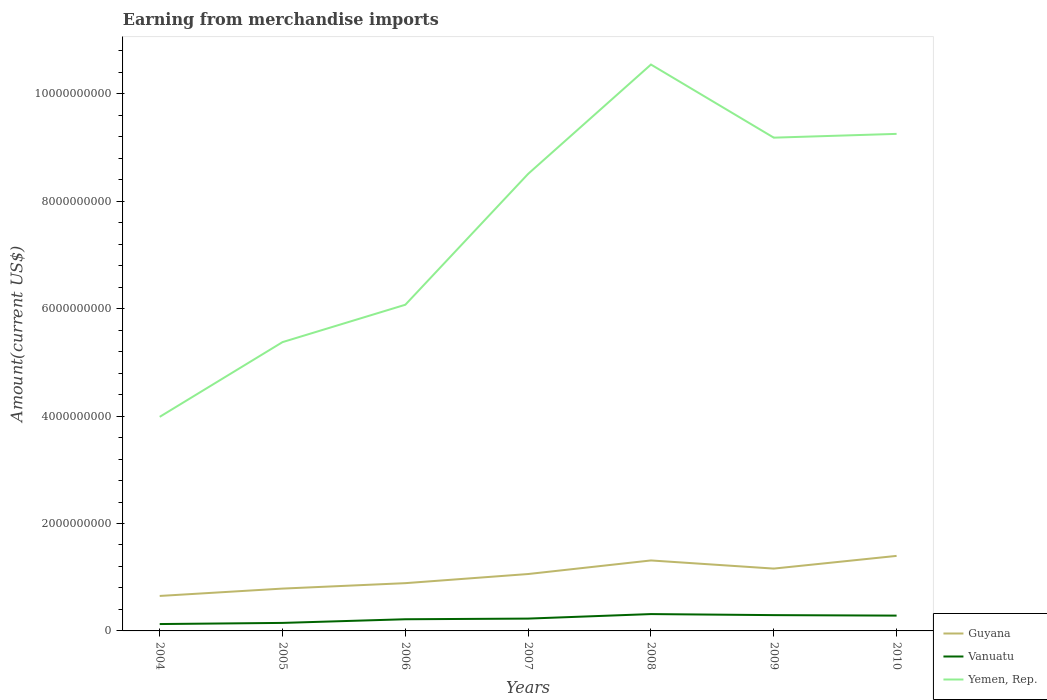How many different coloured lines are there?
Offer a terse response. 3. Does the line corresponding to Guyana intersect with the line corresponding to Yemen, Rep.?
Give a very brief answer. No. Is the number of lines equal to the number of legend labels?
Offer a very short reply. Yes. Across all years, what is the maximum amount earned from merchandise imports in Yemen, Rep.?
Provide a short and direct response. 3.99e+09. In which year was the amount earned from merchandise imports in Vanuatu maximum?
Your response must be concise. 2004. What is the total amount earned from merchandise imports in Guyana in the graph?
Your answer should be very brief. -1.37e+08. What is the difference between the highest and the second highest amount earned from merchandise imports in Vanuatu?
Give a very brief answer. 1.86e+08. Is the amount earned from merchandise imports in Yemen, Rep. strictly greater than the amount earned from merchandise imports in Guyana over the years?
Provide a succinct answer. No. How many lines are there?
Keep it short and to the point. 3. Does the graph contain grids?
Provide a short and direct response. No. Where does the legend appear in the graph?
Give a very brief answer. Bottom right. How are the legend labels stacked?
Offer a very short reply. Vertical. What is the title of the graph?
Provide a short and direct response. Earning from merchandise imports. What is the label or title of the Y-axis?
Provide a short and direct response. Amount(current US$). What is the Amount(current US$) of Guyana in 2004?
Provide a succinct answer. 6.51e+08. What is the Amount(current US$) of Vanuatu in 2004?
Ensure brevity in your answer.  1.28e+08. What is the Amount(current US$) in Yemen, Rep. in 2004?
Provide a short and direct response. 3.99e+09. What is the Amount(current US$) of Guyana in 2005?
Ensure brevity in your answer.  7.88e+08. What is the Amount(current US$) in Vanuatu in 2005?
Your response must be concise. 1.49e+08. What is the Amount(current US$) of Yemen, Rep. in 2005?
Provide a short and direct response. 5.38e+09. What is the Amount(current US$) of Guyana in 2006?
Provide a succinct answer. 8.89e+08. What is the Amount(current US$) of Vanuatu in 2006?
Your response must be concise. 2.17e+08. What is the Amount(current US$) of Yemen, Rep. in 2006?
Offer a very short reply. 6.07e+09. What is the Amount(current US$) of Guyana in 2007?
Provide a short and direct response. 1.06e+09. What is the Amount(current US$) in Vanuatu in 2007?
Your answer should be very brief. 2.29e+08. What is the Amount(current US$) of Yemen, Rep. in 2007?
Give a very brief answer. 8.51e+09. What is the Amount(current US$) of Guyana in 2008?
Your answer should be compact. 1.31e+09. What is the Amount(current US$) in Vanuatu in 2008?
Provide a succinct answer. 3.14e+08. What is the Amount(current US$) in Yemen, Rep. in 2008?
Your answer should be compact. 1.05e+1. What is the Amount(current US$) of Guyana in 2009?
Make the answer very short. 1.16e+09. What is the Amount(current US$) in Vanuatu in 2009?
Keep it short and to the point. 2.94e+08. What is the Amount(current US$) of Yemen, Rep. in 2009?
Make the answer very short. 9.18e+09. What is the Amount(current US$) of Guyana in 2010?
Provide a succinct answer. 1.40e+09. What is the Amount(current US$) in Vanuatu in 2010?
Your answer should be very brief. 2.85e+08. What is the Amount(current US$) of Yemen, Rep. in 2010?
Your answer should be very brief. 9.26e+09. Across all years, what is the maximum Amount(current US$) in Guyana?
Provide a succinct answer. 1.40e+09. Across all years, what is the maximum Amount(current US$) of Vanuatu?
Make the answer very short. 3.14e+08. Across all years, what is the maximum Amount(current US$) of Yemen, Rep.?
Make the answer very short. 1.05e+1. Across all years, what is the minimum Amount(current US$) in Guyana?
Provide a succinct answer. 6.51e+08. Across all years, what is the minimum Amount(current US$) in Vanuatu?
Provide a succinct answer. 1.28e+08. Across all years, what is the minimum Amount(current US$) in Yemen, Rep.?
Ensure brevity in your answer.  3.99e+09. What is the total Amount(current US$) of Guyana in the graph?
Offer a terse response. 7.26e+09. What is the total Amount(current US$) of Vanuatu in the graph?
Offer a very short reply. 1.62e+09. What is the total Amount(current US$) of Yemen, Rep. in the graph?
Your answer should be very brief. 5.29e+1. What is the difference between the Amount(current US$) in Guyana in 2004 and that in 2005?
Keep it short and to the point. -1.37e+08. What is the difference between the Amount(current US$) of Vanuatu in 2004 and that in 2005?
Keep it short and to the point. -2.12e+07. What is the difference between the Amount(current US$) of Yemen, Rep. in 2004 and that in 2005?
Your answer should be compact. -1.39e+09. What is the difference between the Amount(current US$) of Guyana in 2004 and that in 2006?
Your answer should be very brief. -2.38e+08. What is the difference between the Amount(current US$) in Vanuatu in 2004 and that in 2006?
Offer a terse response. -8.93e+07. What is the difference between the Amount(current US$) in Yemen, Rep. in 2004 and that in 2006?
Provide a short and direct response. -2.09e+09. What is the difference between the Amount(current US$) in Guyana in 2004 and that in 2007?
Provide a short and direct response. -4.08e+08. What is the difference between the Amount(current US$) in Vanuatu in 2004 and that in 2007?
Ensure brevity in your answer.  -1.01e+08. What is the difference between the Amount(current US$) in Yemen, Rep. in 2004 and that in 2007?
Provide a short and direct response. -4.52e+09. What is the difference between the Amount(current US$) in Guyana in 2004 and that in 2008?
Give a very brief answer. -6.61e+08. What is the difference between the Amount(current US$) in Vanuatu in 2004 and that in 2008?
Provide a short and direct response. -1.86e+08. What is the difference between the Amount(current US$) in Yemen, Rep. in 2004 and that in 2008?
Your answer should be compact. -6.56e+09. What is the difference between the Amount(current US$) in Guyana in 2004 and that in 2009?
Offer a very short reply. -5.09e+08. What is the difference between the Amount(current US$) of Vanuatu in 2004 and that in 2009?
Keep it short and to the point. -1.66e+08. What is the difference between the Amount(current US$) of Yemen, Rep. in 2004 and that in 2009?
Keep it short and to the point. -5.20e+09. What is the difference between the Amount(current US$) of Guyana in 2004 and that in 2010?
Offer a very short reply. -7.46e+08. What is the difference between the Amount(current US$) in Vanuatu in 2004 and that in 2010?
Your answer should be very brief. -1.57e+08. What is the difference between the Amount(current US$) in Yemen, Rep. in 2004 and that in 2010?
Provide a short and direct response. -5.27e+09. What is the difference between the Amount(current US$) of Guyana in 2005 and that in 2006?
Your answer should be compact. -1.01e+08. What is the difference between the Amount(current US$) of Vanuatu in 2005 and that in 2006?
Keep it short and to the point. -6.81e+07. What is the difference between the Amount(current US$) in Yemen, Rep. in 2005 and that in 2006?
Your answer should be very brief. -6.96e+08. What is the difference between the Amount(current US$) in Guyana in 2005 and that in 2007?
Provide a short and direct response. -2.71e+08. What is the difference between the Amount(current US$) of Vanuatu in 2005 and that in 2007?
Your answer should be compact. -8.03e+07. What is the difference between the Amount(current US$) of Yemen, Rep. in 2005 and that in 2007?
Your answer should be compact. -3.13e+09. What is the difference between the Amount(current US$) in Guyana in 2005 and that in 2008?
Your response must be concise. -5.24e+08. What is the difference between the Amount(current US$) in Vanuatu in 2005 and that in 2008?
Offer a very short reply. -1.64e+08. What is the difference between the Amount(current US$) of Yemen, Rep. in 2005 and that in 2008?
Provide a succinct answer. -5.17e+09. What is the difference between the Amount(current US$) in Guyana in 2005 and that in 2009?
Your answer should be compact. -3.72e+08. What is the difference between the Amount(current US$) in Vanuatu in 2005 and that in 2009?
Offer a terse response. -1.45e+08. What is the difference between the Amount(current US$) in Yemen, Rep. in 2005 and that in 2009?
Provide a short and direct response. -3.81e+09. What is the difference between the Amount(current US$) in Guyana in 2005 and that in 2010?
Offer a very short reply. -6.09e+08. What is the difference between the Amount(current US$) in Vanuatu in 2005 and that in 2010?
Provide a short and direct response. -1.36e+08. What is the difference between the Amount(current US$) of Yemen, Rep. in 2005 and that in 2010?
Make the answer very short. -3.88e+09. What is the difference between the Amount(current US$) of Guyana in 2006 and that in 2007?
Provide a succinct answer. -1.70e+08. What is the difference between the Amount(current US$) of Vanuatu in 2006 and that in 2007?
Your answer should be compact. -1.22e+07. What is the difference between the Amount(current US$) of Yemen, Rep. in 2006 and that in 2007?
Ensure brevity in your answer.  -2.44e+09. What is the difference between the Amount(current US$) of Guyana in 2006 and that in 2008?
Offer a terse response. -4.23e+08. What is the difference between the Amount(current US$) in Vanuatu in 2006 and that in 2008?
Your answer should be very brief. -9.63e+07. What is the difference between the Amount(current US$) in Yemen, Rep. in 2006 and that in 2008?
Offer a terse response. -4.47e+09. What is the difference between the Amount(current US$) in Guyana in 2006 and that in 2009?
Ensure brevity in your answer.  -2.71e+08. What is the difference between the Amount(current US$) in Vanuatu in 2006 and that in 2009?
Provide a short and direct response. -7.68e+07. What is the difference between the Amount(current US$) of Yemen, Rep. in 2006 and that in 2009?
Keep it short and to the point. -3.11e+09. What is the difference between the Amount(current US$) of Guyana in 2006 and that in 2010?
Provide a short and direct response. -5.08e+08. What is the difference between the Amount(current US$) of Vanuatu in 2006 and that in 2010?
Give a very brief answer. -6.78e+07. What is the difference between the Amount(current US$) in Yemen, Rep. in 2006 and that in 2010?
Ensure brevity in your answer.  -3.18e+09. What is the difference between the Amount(current US$) in Guyana in 2007 and that in 2008?
Keep it short and to the point. -2.53e+08. What is the difference between the Amount(current US$) in Vanuatu in 2007 and that in 2008?
Give a very brief answer. -8.41e+07. What is the difference between the Amount(current US$) of Yemen, Rep. in 2007 and that in 2008?
Keep it short and to the point. -2.04e+09. What is the difference between the Amount(current US$) in Guyana in 2007 and that in 2009?
Offer a very short reply. -1.01e+08. What is the difference between the Amount(current US$) in Vanuatu in 2007 and that in 2009?
Provide a succinct answer. -6.47e+07. What is the difference between the Amount(current US$) in Yemen, Rep. in 2007 and that in 2009?
Make the answer very short. -6.74e+08. What is the difference between the Amount(current US$) of Guyana in 2007 and that in 2010?
Offer a terse response. -3.38e+08. What is the difference between the Amount(current US$) of Vanuatu in 2007 and that in 2010?
Provide a short and direct response. -5.56e+07. What is the difference between the Amount(current US$) of Yemen, Rep. in 2007 and that in 2010?
Offer a very short reply. -7.45e+08. What is the difference between the Amount(current US$) of Guyana in 2008 and that in 2009?
Give a very brief answer. 1.52e+08. What is the difference between the Amount(current US$) in Vanuatu in 2008 and that in 2009?
Your answer should be compact. 1.95e+07. What is the difference between the Amount(current US$) in Yemen, Rep. in 2008 and that in 2009?
Give a very brief answer. 1.36e+09. What is the difference between the Amount(current US$) of Guyana in 2008 and that in 2010?
Offer a terse response. -8.49e+07. What is the difference between the Amount(current US$) in Vanuatu in 2008 and that in 2010?
Ensure brevity in your answer.  2.85e+07. What is the difference between the Amount(current US$) of Yemen, Rep. in 2008 and that in 2010?
Provide a succinct answer. 1.29e+09. What is the difference between the Amount(current US$) of Guyana in 2009 and that in 2010?
Ensure brevity in your answer.  -2.36e+08. What is the difference between the Amount(current US$) of Vanuatu in 2009 and that in 2010?
Ensure brevity in your answer.  9.04e+06. What is the difference between the Amount(current US$) of Yemen, Rep. in 2009 and that in 2010?
Make the answer very short. -7.05e+07. What is the difference between the Amount(current US$) in Guyana in 2004 and the Amount(current US$) in Vanuatu in 2005?
Keep it short and to the point. 5.02e+08. What is the difference between the Amount(current US$) in Guyana in 2004 and the Amount(current US$) in Yemen, Rep. in 2005?
Provide a short and direct response. -4.73e+09. What is the difference between the Amount(current US$) in Vanuatu in 2004 and the Amount(current US$) in Yemen, Rep. in 2005?
Your answer should be very brief. -5.25e+09. What is the difference between the Amount(current US$) of Guyana in 2004 and the Amount(current US$) of Vanuatu in 2006?
Give a very brief answer. 4.34e+08. What is the difference between the Amount(current US$) in Guyana in 2004 and the Amount(current US$) in Yemen, Rep. in 2006?
Ensure brevity in your answer.  -5.42e+09. What is the difference between the Amount(current US$) of Vanuatu in 2004 and the Amount(current US$) of Yemen, Rep. in 2006?
Your answer should be compact. -5.95e+09. What is the difference between the Amount(current US$) in Guyana in 2004 and the Amount(current US$) in Vanuatu in 2007?
Your answer should be very brief. 4.22e+08. What is the difference between the Amount(current US$) of Guyana in 2004 and the Amount(current US$) of Yemen, Rep. in 2007?
Provide a short and direct response. -7.86e+09. What is the difference between the Amount(current US$) in Vanuatu in 2004 and the Amount(current US$) in Yemen, Rep. in 2007?
Ensure brevity in your answer.  -8.38e+09. What is the difference between the Amount(current US$) in Guyana in 2004 and the Amount(current US$) in Vanuatu in 2008?
Provide a short and direct response. 3.38e+08. What is the difference between the Amount(current US$) of Guyana in 2004 and the Amount(current US$) of Yemen, Rep. in 2008?
Your response must be concise. -9.89e+09. What is the difference between the Amount(current US$) in Vanuatu in 2004 and the Amount(current US$) in Yemen, Rep. in 2008?
Your answer should be very brief. -1.04e+1. What is the difference between the Amount(current US$) in Guyana in 2004 and the Amount(current US$) in Vanuatu in 2009?
Make the answer very short. 3.57e+08. What is the difference between the Amount(current US$) in Guyana in 2004 and the Amount(current US$) in Yemen, Rep. in 2009?
Your answer should be very brief. -8.53e+09. What is the difference between the Amount(current US$) in Vanuatu in 2004 and the Amount(current US$) in Yemen, Rep. in 2009?
Your response must be concise. -9.06e+09. What is the difference between the Amount(current US$) of Guyana in 2004 and the Amount(current US$) of Vanuatu in 2010?
Give a very brief answer. 3.66e+08. What is the difference between the Amount(current US$) of Guyana in 2004 and the Amount(current US$) of Yemen, Rep. in 2010?
Provide a succinct answer. -8.60e+09. What is the difference between the Amount(current US$) in Vanuatu in 2004 and the Amount(current US$) in Yemen, Rep. in 2010?
Give a very brief answer. -9.13e+09. What is the difference between the Amount(current US$) in Guyana in 2005 and the Amount(current US$) in Vanuatu in 2006?
Ensure brevity in your answer.  5.71e+08. What is the difference between the Amount(current US$) in Guyana in 2005 and the Amount(current US$) in Yemen, Rep. in 2006?
Your response must be concise. -5.29e+09. What is the difference between the Amount(current US$) of Vanuatu in 2005 and the Amount(current US$) of Yemen, Rep. in 2006?
Provide a succinct answer. -5.92e+09. What is the difference between the Amount(current US$) in Guyana in 2005 and the Amount(current US$) in Vanuatu in 2007?
Your response must be concise. 5.59e+08. What is the difference between the Amount(current US$) of Guyana in 2005 and the Amount(current US$) of Yemen, Rep. in 2007?
Your response must be concise. -7.72e+09. What is the difference between the Amount(current US$) of Vanuatu in 2005 and the Amount(current US$) of Yemen, Rep. in 2007?
Keep it short and to the point. -8.36e+09. What is the difference between the Amount(current US$) in Guyana in 2005 and the Amount(current US$) in Vanuatu in 2008?
Give a very brief answer. 4.75e+08. What is the difference between the Amount(current US$) in Guyana in 2005 and the Amount(current US$) in Yemen, Rep. in 2008?
Provide a succinct answer. -9.76e+09. What is the difference between the Amount(current US$) of Vanuatu in 2005 and the Amount(current US$) of Yemen, Rep. in 2008?
Your answer should be compact. -1.04e+1. What is the difference between the Amount(current US$) of Guyana in 2005 and the Amount(current US$) of Vanuatu in 2009?
Keep it short and to the point. 4.94e+08. What is the difference between the Amount(current US$) of Guyana in 2005 and the Amount(current US$) of Yemen, Rep. in 2009?
Offer a terse response. -8.40e+09. What is the difference between the Amount(current US$) in Vanuatu in 2005 and the Amount(current US$) in Yemen, Rep. in 2009?
Give a very brief answer. -9.04e+09. What is the difference between the Amount(current US$) of Guyana in 2005 and the Amount(current US$) of Vanuatu in 2010?
Ensure brevity in your answer.  5.03e+08. What is the difference between the Amount(current US$) of Guyana in 2005 and the Amount(current US$) of Yemen, Rep. in 2010?
Keep it short and to the point. -8.47e+09. What is the difference between the Amount(current US$) of Vanuatu in 2005 and the Amount(current US$) of Yemen, Rep. in 2010?
Offer a terse response. -9.11e+09. What is the difference between the Amount(current US$) of Guyana in 2006 and the Amount(current US$) of Vanuatu in 2007?
Keep it short and to the point. 6.60e+08. What is the difference between the Amount(current US$) of Guyana in 2006 and the Amount(current US$) of Yemen, Rep. in 2007?
Provide a succinct answer. -7.62e+09. What is the difference between the Amount(current US$) of Vanuatu in 2006 and the Amount(current US$) of Yemen, Rep. in 2007?
Keep it short and to the point. -8.29e+09. What is the difference between the Amount(current US$) of Guyana in 2006 and the Amount(current US$) of Vanuatu in 2008?
Offer a very short reply. 5.76e+08. What is the difference between the Amount(current US$) in Guyana in 2006 and the Amount(current US$) in Yemen, Rep. in 2008?
Provide a short and direct response. -9.66e+09. What is the difference between the Amount(current US$) in Vanuatu in 2006 and the Amount(current US$) in Yemen, Rep. in 2008?
Your answer should be very brief. -1.03e+1. What is the difference between the Amount(current US$) in Guyana in 2006 and the Amount(current US$) in Vanuatu in 2009?
Your answer should be compact. 5.95e+08. What is the difference between the Amount(current US$) in Guyana in 2006 and the Amount(current US$) in Yemen, Rep. in 2009?
Your answer should be very brief. -8.30e+09. What is the difference between the Amount(current US$) of Vanuatu in 2006 and the Amount(current US$) of Yemen, Rep. in 2009?
Your answer should be compact. -8.97e+09. What is the difference between the Amount(current US$) of Guyana in 2006 and the Amount(current US$) of Vanuatu in 2010?
Offer a terse response. 6.04e+08. What is the difference between the Amount(current US$) in Guyana in 2006 and the Amount(current US$) in Yemen, Rep. in 2010?
Make the answer very short. -8.37e+09. What is the difference between the Amount(current US$) in Vanuatu in 2006 and the Amount(current US$) in Yemen, Rep. in 2010?
Offer a terse response. -9.04e+09. What is the difference between the Amount(current US$) of Guyana in 2007 and the Amount(current US$) of Vanuatu in 2008?
Offer a terse response. 7.46e+08. What is the difference between the Amount(current US$) in Guyana in 2007 and the Amount(current US$) in Yemen, Rep. in 2008?
Keep it short and to the point. -9.49e+09. What is the difference between the Amount(current US$) in Vanuatu in 2007 and the Amount(current US$) in Yemen, Rep. in 2008?
Provide a short and direct response. -1.03e+1. What is the difference between the Amount(current US$) in Guyana in 2007 and the Amount(current US$) in Vanuatu in 2009?
Provide a short and direct response. 7.65e+08. What is the difference between the Amount(current US$) of Guyana in 2007 and the Amount(current US$) of Yemen, Rep. in 2009?
Keep it short and to the point. -8.13e+09. What is the difference between the Amount(current US$) of Vanuatu in 2007 and the Amount(current US$) of Yemen, Rep. in 2009?
Your response must be concise. -8.96e+09. What is the difference between the Amount(current US$) in Guyana in 2007 and the Amount(current US$) in Vanuatu in 2010?
Your answer should be very brief. 7.74e+08. What is the difference between the Amount(current US$) in Guyana in 2007 and the Amount(current US$) in Yemen, Rep. in 2010?
Give a very brief answer. -8.20e+09. What is the difference between the Amount(current US$) in Vanuatu in 2007 and the Amount(current US$) in Yemen, Rep. in 2010?
Offer a terse response. -9.03e+09. What is the difference between the Amount(current US$) in Guyana in 2008 and the Amount(current US$) in Vanuatu in 2009?
Give a very brief answer. 1.02e+09. What is the difference between the Amount(current US$) in Guyana in 2008 and the Amount(current US$) in Yemen, Rep. in 2009?
Provide a short and direct response. -7.87e+09. What is the difference between the Amount(current US$) in Vanuatu in 2008 and the Amount(current US$) in Yemen, Rep. in 2009?
Ensure brevity in your answer.  -8.87e+09. What is the difference between the Amount(current US$) of Guyana in 2008 and the Amount(current US$) of Vanuatu in 2010?
Provide a succinct answer. 1.03e+09. What is the difference between the Amount(current US$) in Guyana in 2008 and the Amount(current US$) in Yemen, Rep. in 2010?
Give a very brief answer. -7.94e+09. What is the difference between the Amount(current US$) in Vanuatu in 2008 and the Amount(current US$) in Yemen, Rep. in 2010?
Provide a short and direct response. -8.94e+09. What is the difference between the Amount(current US$) of Guyana in 2009 and the Amount(current US$) of Vanuatu in 2010?
Give a very brief answer. 8.76e+08. What is the difference between the Amount(current US$) in Guyana in 2009 and the Amount(current US$) in Yemen, Rep. in 2010?
Keep it short and to the point. -8.09e+09. What is the difference between the Amount(current US$) of Vanuatu in 2009 and the Amount(current US$) of Yemen, Rep. in 2010?
Offer a very short reply. -8.96e+09. What is the average Amount(current US$) of Guyana per year?
Provide a succinct answer. 1.04e+09. What is the average Amount(current US$) of Vanuatu per year?
Your answer should be very brief. 2.31e+08. What is the average Amount(current US$) of Yemen, Rep. per year?
Your response must be concise. 7.56e+09. In the year 2004, what is the difference between the Amount(current US$) of Guyana and Amount(current US$) of Vanuatu?
Provide a short and direct response. 5.23e+08. In the year 2004, what is the difference between the Amount(current US$) of Guyana and Amount(current US$) of Yemen, Rep.?
Your answer should be very brief. -3.33e+09. In the year 2004, what is the difference between the Amount(current US$) of Vanuatu and Amount(current US$) of Yemen, Rep.?
Ensure brevity in your answer.  -3.86e+09. In the year 2005, what is the difference between the Amount(current US$) of Guyana and Amount(current US$) of Vanuatu?
Offer a very short reply. 6.39e+08. In the year 2005, what is the difference between the Amount(current US$) of Guyana and Amount(current US$) of Yemen, Rep.?
Provide a succinct answer. -4.59e+09. In the year 2005, what is the difference between the Amount(current US$) in Vanuatu and Amount(current US$) in Yemen, Rep.?
Give a very brief answer. -5.23e+09. In the year 2006, what is the difference between the Amount(current US$) in Guyana and Amount(current US$) in Vanuatu?
Give a very brief answer. 6.72e+08. In the year 2006, what is the difference between the Amount(current US$) of Guyana and Amount(current US$) of Yemen, Rep.?
Give a very brief answer. -5.18e+09. In the year 2006, what is the difference between the Amount(current US$) of Vanuatu and Amount(current US$) of Yemen, Rep.?
Give a very brief answer. -5.86e+09. In the year 2007, what is the difference between the Amount(current US$) in Guyana and Amount(current US$) in Vanuatu?
Your answer should be compact. 8.30e+08. In the year 2007, what is the difference between the Amount(current US$) in Guyana and Amount(current US$) in Yemen, Rep.?
Keep it short and to the point. -7.45e+09. In the year 2007, what is the difference between the Amount(current US$) of Vanuatu and Amount(current US$) of Yemen, Rep.?
Your response must be concise. -8.28e+09. In the year 2008, what is the difference between the Amount(current US$) of Guyana and Amount(current US$) of Vanuatu?
Keep it short and to the point. 9.99e+08. In the year 2008, what is the difference between the Amount(current US$) in Guyana and Amount(current US$) in Yemen, Rep.?
Give a very brief answer. -9.23e+09. In the year 2008, what is the difference between the Amount(current US$) in Vanuatu and Amount(current US$) in Yemen, Rep.?
Your answer should be compact. -1.02e+1. In the year 2009, what is the difference between the Amount(current US$) in Guyana and Amount(current US$) in Vanuatu?
Your answer should be compact. 8.67e+08. In the year 2009, what is the difference between the Amount(current US$) of Guyana and Amount(current US$) of Yemen, Rep.?
Offer a terse response. -8.02e+09. In the year 2009, what is the difference between the Amount(current US$) in Vanuatu and Amount(current US$) in Yemen, Rep.?
Your response must be concise. -8.89e+09. In the year 2010, what is the difference between the Amount(current US$) in Guyana and Amount(current US$) in Vanuatu?
Your response must be concise. 1.11e+09. In the year 2010, what is the difference between the Amount(current US$) of Guyana and Amount(current US$) of Yemen, Rep.?
Make the answer very short. -7.86e+09. In the year 2010, what is the difference between the Amount(current US$) of Vanuatu and Amount(current US$) of Yemen, Rep.?
Provide a succinct answer. -8.97e+09. What is the ratio of the Amount(current US$) of Guyana in 2004 to that in 2005?
Offer a very short reply. 0.83. What is the ratio of the Amount(current US$) of Vanuatu in 2004 to that in 2005?
Provide a short and direct response. 0.86. What is the ratio of the Amount(current US$) of Yemen, Rep. in 2004 to that in 2005?
Provide a succinct answer. 0.74. What is the ratio of the Amount(current US$) in Guyana in 2004 to that in 2006?
Your answer should be very brief. 0.73. What is the ratio of the Amount(current US$) of Vanuatu in 2004 to that in 2006?
Provide a short and direct response. 0.59. What is the ratio of the Amount(current US$) in Yemen, Rep. in 2004 to that in 2006?
Your response must be concise. 0.66. What is the ratio of the Amount(current US$) of Guyana in 2004 to that in 2007?
Your answer should be compact. 0.61. What is the ratio of the Amount(current US$) of Vanuatu in 2004 to that in 2007?
Offer a terse response. 0.56. What is the ratio of the Amount(current US$) in Yemen, Rep. in 2004 to that in 2007?
Give a very brief answer. 0.47. What is the ratio of the Amount(current US$) of Guyana in 2004 to that in 2008?
Provide a short and direct response. 0.5. What is the ratio of the Amount(current US$) of Vanuatu in 2004 to that in 2008?
Provide a succinct answer. 0.41. What is the ratio of the Amount(current US$) in Yemen, Rep. in 2004 to that in 2008?
Offer a very short reply. 0.38. What is the ratio of the Amount(current US$) of Guyana in 2004 to that in 2009?
Your answer should be compact. 0.56. What is the ratio of the Amount(current US$) of Vanuatu in 2004 to that in 2009?
Offer a very short reply. 0.44. What is the ratio of the Amount(current US$) in Yemen, Rep. in 2004 to that in 2009?
Your response must be concise. 0.43. What is the ratio of the Amount(current US$) of Guyana in 2004 to that in 2010?
Provide a succinct answer. 0.47. What is the ratio of the Amount(current US$) of Vanuatu in 2004 to that in 2010?
Your answer should be very brief. 0.45. What is the ratio of the Amount(current US$) of Yemen, Rep. in 2004 to that in 2010?
Keep it short and to the point. 0.43. What is the ratio of the Amount(current US$) in Guyana in 2005 to that in 2006?
Your answer should be very brief. 0.89. What is the ratio of the Amount(current US$) of Vanuatu in 2005 to that in 2006?
Your response must be concise. 0.69. What is the ratio of the Amount(current US$) of Yemen, Rep. in 2005 to that in 2006?
Give a very brief answer. 0.89. What is the ratio of the Amount(current US$) of Guyana in 2005 to that in 2007?
Provide a succinct answer. 0.74. What is the ratio of the Amount(current US$) of Vanuatu in 2005 to that in 2007?
Give a very brief answer. 0.65. What is the ratio of the Amount(current US$) in Yemen, Rep. in 2005 to that in 2007?
Make the answer very short. 0.63. What is the ratio of the Amount(current US$) of Guyana in 2005 to that in 2008?
Give a very brief answer. 0.6. What is the ratio of the Amount(current US$) of Vanuatu in 2005 to that in 2008?
Give a very brief answer. 0.48. What is the ratio of the Amount(current US$) in Yemen, Rep. in 2005 to that in 2008?
Your answer should be compact. 0.51. What is the ratio of the Amount(current US$) of Guyana in 2005 to that in 2009?
Offer a very short reply. 0.68. What is the ratio of the Amount(current US$) of Vanuatu in 2005 to that in 2009?
Provide a succinct answer. 0.51. What is the ratio of the Amount(current US$) in Yemen, Rep. in 2005 to that in 2009?
Your answer should be compact. 0.59. What is the ratio of the Amount(current US$) of Guyana in 2005 to that in 2010?
Make the answer very short. 0.56. What is the ratio of the Amount(current US$) in Vanuatu in 2005 to that in 2010?
Offer a very short reply. 0.52. What is the ratio of the Amount(current US$) in Yemen, Rep. in 2005 to that in 2010?
Your answer should be compact. 0.58. What is the ratio of the Amount(current US$) in Guyana in 2006 to that in 2007?
Ensure brevity in your answer.  0.84. What is the ratio of the Amount(current US$) of Vanuatu in 2006 to that in 2007?
Offer a very short reply. 0.95. What is the ratio of the Amount(current US$) in Yemen, Rep. in 2006 to that in 2007?
Make the answer very short. 0.71. What is the ratio of the Amount(current US$) in Guyana in 2006 to that in 2008?
Give a very brief answer. 0.68. What is the ratio of the Amount(current US$) in Vanuatu in 2006 to that in 2008?
Your response must be concise. 0.69. What is the ratio of the Amount(current US$) of Yemen, Rep. in 2006 to that in 2008?
Make the answer very short. 0.58. What is the ratio of the Amount(current US$) of Guyana in 2006 to that in 2009?
Offer a terse response. 0.77. What is the ratio of the Amount(current US$) of Vanuatu in 2006 to that in 2009?
Your response must be concise. 0.74. What is the ratio of the Amount(current US$) in Yemen, Rep. in 2006 to that in 2009?
Give a very brief answer. 0.66. What is the ratio of the Amount(current US$) of Guyana in 2006 to that in 2010?
Provide a succinct answer. 0.64. What is the ratio of the Amount(current US$) of Vanuatu in 2006 to that in 2010?
Make the answer very short. 0.76. What is the ratio of the Amount(current US$) in Yemen, Rep. in 2006 to that in 2010?
Make the answer very short. 0.66. What is the ratio of the Amount(current US$) of Guyana in 2007 to that in 2008?
Ensure brevity in your answer.  0.81. What is the ratio of the Amount(current US$) in Vanuatu in 2007 to that in 2008?
Offer a terse response. 0.73. What is the ratio of the Amount(current US$) of Yemen, Rep. in 2007 to that in 2008?
Ensure brevity in your answer.  0.81. What is the ratio of the Amount(current US$) of Guyana in 2007 to that in 2009?
Your answer should be very brief. 0.91. What is the ratio of the Amount(current US$) in Vanuatu in 2007 to that in 2009?
Provide a succinct answer. 0.78. What is the ratio of the Amount(current US$) of Yemen, Rep. in 2007 to that in 2009?
Offer a terse response. 0.93. What is the ratio of the Amount(current US$) in Guyana in 2007 to that in 2010?
Give a very brief answer. 0.76. What is the ratio of the Amount(current US$) of Vanuatu in 2007 to that in 2010?
Provide a succinct answer. 0.8. What is the ratio of the Amount(current US$) of Yemen, Rep. in 2007 to that in 2010?
Offer a terse response. 0.92. What is the ratio of the Amount(current US$) of Guyana in 2008 to that in 2009?
Your answer should be very brief. 1.13. What is the ratio of the Amount(current US$) of Vanuatu in 2008 to that in 2009?
Offer a very short reply. 1.07. What is the ratio of the Amount(current US$) in Yemen, Rep. in 2008 to that in 2009?
Your answer should be compact. 1.15. What is the ratio of the Amount(current US$) in Guyana in 2008 to that in 2010?
Provide a short and direct response. 0.94. What is the ratio of the Amount(current US$) of Vanuatu in 2008 to that in 2010?
Provide a succinct answer. 1.1. What is the ratio of the Amount(current US$) of Yemen, Rep. in 2008 to that in 2010?
Your answer should be compact. 1.14. What is the ratio of the Amount(current US$) in Guyana in 2009 to that in 2010?
Ensure brevity in your answer.  0.83. What is the ratio of the Amount(current US$) in Vanuatu in 2009 to that in 2010?
Give a very brief answer. 1.03. What is the ratio of the Amount(current US$) of Yemen, Rep. in 2009 to that in 2010?
Keep it short and to the point. 0.99. What is the difference between the highest and the second highest Amount(current US$) in Guyana?
Your answer should be compact. 8.49e+07. What is the difference between the highest and the second highest Amount(current US$) of Vanuatu?
Your response must be concise. 1.95e+07. What is the difference between the highest and the second highest Amount(current US$) in Yemen, Rep.?
Give a very brief answer. 1.29e+09. What is the difference between the highest and the lowest Amount(current US$) in Guyana?
Your answer should be very brief. 7.46e+08. What is the difference between the highest and the lowest Amount(current US$) in Vanuatu?
Offer a very short reply. 1.86e+08. What is the difference between the highest and the lowest Amount(current US$) in Yemen, Rep.?
Your response must be concise. 6.56e+09. 